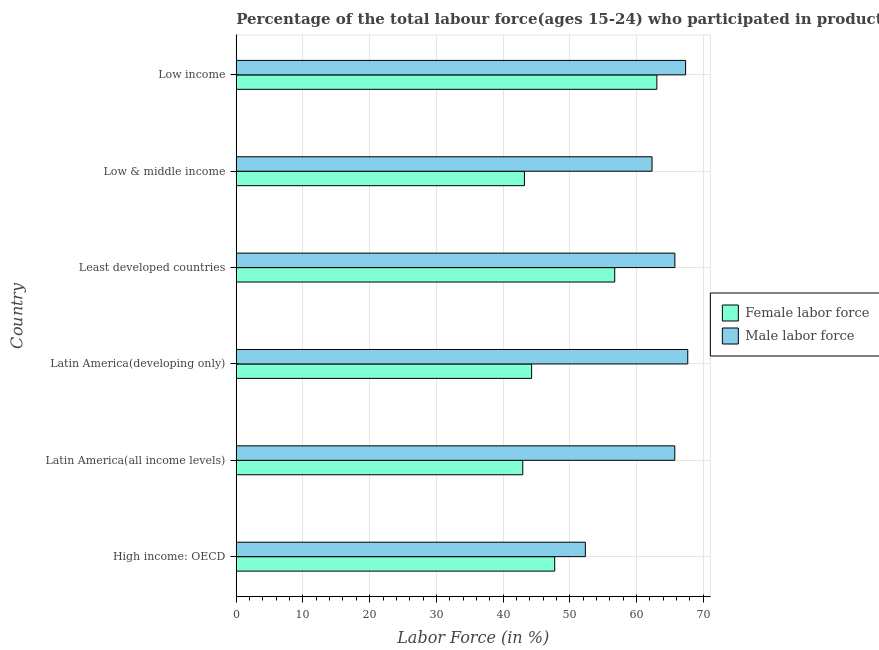How many different coloured bars are there?
Ensure brevity in your answer.  2. How many groups of bars are there?
Provide a succinct answer. 6. Are the number of bars per tick equal to the number of legend labels?
Keep it short and to the point. Yes. Are the number of bars on each tick of the Y-axis equal?
Provide a succinct answer. Yes. How many bars are there on the 5th tick from the bottom?
Your answer should be compact. 2. What is the label of the 1st group of bars from the top?
Offer a very short reply. Low income. What is the percentage of male labour force in Low income?
Give a very brief answer. 67.37. Across all countries, what is the maximum percentage of male labour force?
Offer a terse response. 67.69. Across all countries, what is the minimum percentage of male labour force?
Make the answer very short. 52.34. In which country was the percentage of male labour force maximum?
Provide a short and direct response. Latin America(developing only). In which country was the percentage of female labor force minimum?
Offer a very short reply. Latin America(all income levels). What is the total percentage of female labor force in the graph?
Offer a very short reply. 297.97. What is the difference between the percentage of male labour force in High income: OECD and that in Low & middle income?
Keep it short and to the point. -10. What is the difference between the percentage of female labor force in High income: OECD and the percentage of male labour force in Latin America(all income levels)?
Your response must be concise. -18.01. What is the average percentage of male labour force per country?
Keep it short and to the point. 63.54. What is the difference between the percentage of male labour force and percentage of female labor force in Low income?
Give a very brief answer. 4.31. What is the ratio of the percentage of male labour force in High income: OECD to that in Least developed countries?
Keep it short and to the point. 0.8. Is the percentage of male labour force in High income: OECD less than that in Least developed countries?
Your response must be concise. Yes. Is the difference between the percentage of female labor force in High income: OECD and Low income greater than the difference between the percentage of male labour force in High income: OECD and Low income?
Offer a very short reply. No. What is the difference between the highest and the second highest percentage of female labor force?
Your response must be concise. 6.32. What is the difference between the highest and the lowest percentage of female labor force?
Make the answer very short. 20.1. In how many countries, is the percentage of male labour force greater than the average percentage of male labour force taken over all countries?
Offer a very short reply. 4. Is the sum of the percentage of male labour force in Latin America(all income levels) and Latin America(developing only) greater than the maximum percentage of female labor force across all countries?
Your answer should be compact. Yes. What does the 2nd bar from the top in Latin America(developing only) represents?
Give a very brief answer. Female labor force. What does the 1st bar from the bottom in Low & middle income represents?
Keep it short and to the point. Female labor force. How many bars are there?
Offer a terse response. 12. Are all the bars in the graph horizontal?
Your answer should be compact. Yes. What is the difference between two consecutive major ticks on the X-axis?
Your answer should be very brief. 10. Does the graph contain any zero values?
Give a very brief answer. No. Does the graph contain grids?
Keep it short and to the point. Yes. How many legend labels are there?
Make the answer very short. 2. What is the title of the graph?
Provide a succinct answer. Percentage of the total labour force(ages 15-24) who participated in production in 2002. Does "Female" appear as one of the legend labels in the graph?
Make the answer very short. No. What is the label or title of the X-axis?
Give a very brief answer. Labor Force (in %). What is the Labor Force (in %) in Female labor force in High income: OECD?
Offer a very short reply. 47.74. What is the Labor Force (in %) in Male labor force in High income: OECD?
Your response must be concise. 52.34. What is the Labor Force (in %) of Female labor force in Latin America(all income levels)?
Your response must be concise. 42.95. What is the Labor Force (in %) in Male labor force in Latin America(all income levels)?
Your answer should be very brief. 65.75. What is the Labor Force (in %) in Female labor force in Latin America(developing only)?
Offer a very short reply. 44.28. What is the Labor Force (in %) in Male labor force in Latin America(developing only)?
Give a very brief answer. 67.69. What is the Labor Force (in %) of Female labor force in Least developed countries?
Make the answer very short. 56.74. What is the Labor Force (in %) of Male labor force in Least developed countries?
Give a very brief answer. 65.76. What is the Labor Force (in %) of Female labor force in Low & middle income?
Keep it short and to the point. 43.2. What is the Labor Force (in %) of Male labor force in Low & middle income?
Your answer should be very brief. 62.33. What is the Labor Force (in %) of Female labor force in Low income?
Give a very brief answer. 63.06. What is the Labor Force (in %) of Male labor force in Low income?
Provide a succinct answer. 67.37. Across all countries, what is the maximum Labor Force (in %) of Female labor force?
Provide a succinct answer. 63.06. Across all countries, what is the maximum Labor Force (in %) in Male labor force?
Your answer should be very brief. 67.69. Across all countries, what is the minimum Labor Force (in %) of Female labor force?
Give a very brief answer. 42.95. Across all countries, what is the minimum Labor Force (in %) in Male labor force?
Keep it short and to the point. 52.34. What is the total Labor Force (in %) in Female labor force in the graph?
Ensure brevity in your answer.  297.97. What is the total Labor Force (in %) of Male labor force in the graph?
Give a very brief answer. 381.23. What is the difference between the Labor Force (in %) in Female labor force in High income: OECD and that in Latin America(all income levels)?
Provide a short and direct response. 4.79. What is the difference between the Labor Force (in %) of Male labor force in High income: OECD and that in Latin America(all income levels)?
Offer a very short reply. -13.41. What is the difference between the Labor Force (in %) in Female labor force in High income: OECD and that in Latin America(developing only)?
Ensure brevity in your answer.  3.46. What is the difference between the Labor Force (in %) of Male labor force in High income: OECD and that in Latin America(developing only)?
Your response must be concise. -15.35. What is the difference between the Labor Force (in %) of Female labor force in High income: OECD and that in Least developed countries?
Your response must be concise. -9. What is the difference between the Labor Force (in %) of Male labor force in High income: OECD and that in Least developed countries?
Offer a very short reply. -13.42. What is the difference between the Labor Force (in %) in Female labor force in High income: OECD and that in Low & middle income?
Your answer should be very brief. 4.54. What is the difference between the Labor Force (in %) in Male labor force in High income: OECD and that in Low & middle income?
Keep it short and to the point. -10. What is the difference between the Labor Force (in %) of Female labor force in High income: OECD and that in Low income?
Ensure brevity in your answer.  -15.32. What is the difference between the Labor Force (in %) in Male labor force in High income: OECD and that in Low income?
Your response must be concise. -15.03. What is the difference between the Labor Force (in %) of Female labor force in Latin America(all income levels) and that in Latin America(developing only)?
Your response must be concise. -1.33. What is the difference between the Labor Force (in %) in Male labor force in Latin America(all income levels) and that in Latin America(developing only)?
Your answer should be compact. -1.94. What is the difference between the Labor Force (in %) of Female labor force in Latin America(all income levels) and that in Least developed countries?
Offer a very short reply. -13.78. What is the difference between the Labor Force (in %) in Male labor force in Latin America(all income levels) and that in Least developed countries?
Keep it short and to the point. -0.01. What is the difference between the Labor Force (in %) in Female labor force in Latin America(all income levels) and that in Low & middle income?
Provide a succinct answer. -0.25. What is the difference between the Labor Force (in %) of Male labor force in Latin America(all income levels) and that in Low & middle income?
Ensure brevity in your answer.  3.41. What is the difference between the Labor Force (in %) of Female labor force in Latin America(all income levels) and that in Low income?
Your answer should be very brief. -20.1. What is the difference between the Labor Force (in %) of Male labor force in Latin America(all income levels) and that in Low income?
Offer a very short reply. -1.62. What is the difference between the Labor Force (in %) of Female labor force in Latin America(developing only) and that in Least developed countries?
Your answer should be compact. -12.46. What is the difference between the Labor Force (in %) of Male labor force in Latin America(developing only) and that in Least developed countries?
Offer a terse response. 1.93. What is the difference between the Labor Force (in %) of Male labor force in Latin America(developing only) and that in Low & middle income?
Provide a succinct answer. 5.35. What is the difference between the Labor Force (in %) of Female labor force in Latin America(developing only) and that in Low income?
Ensure brevity in your answer.  -18.77. What is the difference between the Labor Force (in %) of Male labor force in Latin America(developing only) and that in Low income?
Offer a terse response. 0.32. What is the difference between the Labor Force (in %) of Female labor force in Least developed countries and that in Low & middle income?
Give a very brief answer. 13.53. What is the difference between the Labor Force (in %) in Male labor force in Least developed countries and that in Low & middle income?
Your answer should be very brief. 3.42. What is the difference between the Labor Force (in %) in Female labor force in Least developed countries and that in Low income?
Provide a succinct answer. -6.32. What is the difference between the Labor Force (in %) of Male labor force in Least developed countries and that in Low income?
Your response must be concise. -1.61. What is the difference between the Labor Force (in %) in Female labor force in Low & middle income and that in Low income?
Give a very brief answer. -19.85. What is the difference between the Labor Force (in %) of Male labor force in Low & middle income and that in Low income?
Make the answer very short. -5.04. What is the difference between the Labor Force (in %) in Female labor force in High income: OECD and the Labor Force (in %) in Male labor force in Latin America(all income levels)?
Keep it short and to the point. -18.01. What is the difference between the Labor Force (in %) of Female labor force in High income: OECD and the Labor Force (in %) of Male labor force in Latin America(developing only)?
Make the answer very short. -19.95. What is the difference between the Labor Force (in %) in Female labor force in High income: OECD and the Labor Force (in %) in Male labor force in Least developed countries?
Your answer should be very brief. -18.02. What is the difference between the Labor Force (in %) of Female labor force in High income: OECD and the Labor Force (in %) of Male labor force in Low & middle income?
Keep it short and to the point. -14.59. What is the difference between the Labor Force (in %) in Female labor force in High income: OECD and the Labor Force (in %) in Male labor force in Low income?
Your answer should be very brief. -19.63. What is the difference between the Labor Force (in %) in Female labor force in Latin America(all income levels) and the Labor Force (in %) in Male labor force in Latin America(developing only)?
Give a very brief answer. -24.74. What is the difference between the Labor Force (in %) in Female labor force in Latin America(all income levels) and the Labor Force (in %) in Male labor force in Least developed countries?
Make the answer very short. -22.8. What is the difference between the Labor Force (in %) of Female labor force in Latin America(all income levels) and the Labor Force (in %) of Male labor force in Low & middle income?
Keep it short and to the point. -19.38. What is the difference between the Labor Force (in %) of Female labor force in Latin America(all income levels) and the Labor Force (in %) of Male labor force in Low income?
Ensure brevity in your answer.  -24.42. What is the difference between the Labor Force (in %) in Female labor force in Latin America(developing only) and the Labor Force (in %) in Male labor force in Least developed countries?
Ensure brevity in your answer.  -21.48. What is the difference between the Labor Force (in %) of Female labor force in Latin America(developing only) and the Labor Force (in %) of Male labor force in Low & middle income?
Provide a short and direct response. -18.05. What is the difference between the Labor Force (in %) in Female labor force in Latin America(developing only) and the Labor Force (in %) in Male labor force in Low income?
Make the answer very short. -23.09. What is the difference between the Labor Force (in %) of Female labor force in Least developed countries and the Labor Force (in %) of Male labor force in Low & middle income?
Provide a short and direct response. -5.6. What is the difference between the Labor Force (in %) in Female labor force in Least developed countries and the Labor Force (in %) in Male labor force in Low income?
Your answer should be very brief. -10.63. What is the difference between the Labor Force (in %) of Female labor force in Low & middle income and the Labor Force (in %) of Male labor force in Low income?
Ensure brevity in your answer.  -24.16. What is the average Labor Force (in %) of Female labor force per country?
Your answer should be compact. 49.66. What is the average Labor Force (in %) of Male labor force per country?
Your answer should be compact. 63.54. What is the difference between the Labor Force (in %) in Female labor force and Labor Force (in %) in Male labor force in High income: OECD?
Give a very brief answer. -4.6. What is the difference between the Labor Force (in %) of Female labor force and Labor Force (in %) of Male labor force in Latin America(all income levels)?
Your answer should be very brief. -22.79. What is the difference between the Labor Force (in %) of Female labor force and Labor Force (in %) of Male labor force in Latin America(developing only)?
Offer a very short reply. -23.41. What is the difference between the Labor Force (in %) in Female labor force and Labor Force (in %) in Male labor force in Least developed countries?
Your response must be concise. -9.02. What is the difference between the Labor Force (in %) of Female labor force and Labor Force (in %) of Male labor force in Low & middle income?
Provide a succinct answer. -19.13. What is the difference between the Labor Force (in %) in Female labor force and Labor Force (in %) in Male labor force in Low income?
Your response must be concise. -4.31. What is the ratio of the Labor Force (in %) of Female labor force in High income: OECD to that in Latin America(all income levels)?
Offer a terse response. 1.11. What is the ratio of the Labor Force (in %) in Male labor force in High income: OECD to that in Latin America(all income levels)?
Your response must be concise. 0.8. What is the ratio of the Labor Force (in %) in Female labor force in High income: OECD to that in Latin America(developing only)?
Provide a succinct answer. 1.08. What is the ratio of the Labor Force (in %) in Male labor force in High income: OECD to that in Latin America(developing only)?
Make the answer very short. 0.77. What is the ratio of the Labor Force (in %) of Female labor force in High income: OECD to that in Least developed countries?
Ensure brevity in your answer.  0.84. What is the ratio of the Labor Force (in %) of Male labor force in High income: OECD to that in Least developed countries?
Provide a succinct answer. 0.8. What is the ratio of the Labor Force (in %) in Female labor force in High income: OECD to that in Low & middle income?
Provide a succinct answer. 1.1. What is the ratio of the Labor Force (in %) of Male labor force in High income: OECD to that in Low & middle income?
Your response must be concise. 0.84. What is the ratio of the Labor Force (in %) in Female labor force in High income: OECD to that in Low income?
Ensure brevity in your answer.  0.76. What is the ratio of the Labor Force (in %) in Male labor force in High income: OECD to that in Low income?
Give a very brief answer. 0.78. What is the ratio of the Labor Force (in %) of Female labor force in Latin America(all income levels) to that in Latin America(developing only)?
Offer a very short reply. 0.97. What is the ratio of the Labor Force (in %) of Male labor force in Latin America(all income levels) to that in Latin America(developing only)?
Your response must be concise. 0.97. What is the ratio of the Labor Force (in %) of Female labor force in Latin America(all income levels) to that in Least developed countries?
Ensure brevity in your answer.  0.76. What is the ratio of the Labor Force (in %) of Male labor force in Latin America(all income levels) to that in Least developed countries?
Your answer should be compact. 1. What is the ratio of the Labor Force (in %) of Male labor force in Latin America(all income levels) to that in Low & middle income?
Provide a short and direct response. 1.05. What is the ratio of the Labor Force (in %) in Female labor force in Latin America(all income levels) to that in Low income?
Your answer should be very brief. 0.68. What is the ratio of the Labor Force (in %) in Male labor force in Latin America(all income levels) to that in Low income?
Make the answer very short. 0.98. What is the ratio of the Labor Force (in %) in Female labor force in Latin America(developing only) to that in Least developed countries?
Provide a succinct answer. 0.78. What is the ratio of the Labor Force (in %) in Male labor force in Latin America(developing only) to that in Least developed countries?
Give a very brief answer. 1.03. What is the ratio of the Labor Force (in %) in Female labor force in Latin America(developing only) to that in Low & middle income?
Provide a short and direct response. 1.02. What is the ratio of the Labor Force (in %) in Male labor force in Latin America(developing only) to that in Low & middle income?
Provide a short and direct response. 1.09. What is the ratio of the Labor Force (in %) in Female labor force in Latin America(developing only) to that in Low income?
Give a very brief answer. 0.7. What is the ratio of the Labor Force (in %) in Female labor force in Least developed countries to that in Low & middle income?
Provide a succinct answer. 1.31. What is the ratio of the Labor Force (in %) in Male labor force in Least developed countries to that in Low & middle income?
Keep it short and to the point. 1.05. What is the ratio of the Labor Force (in %) in Female labor force in Least developed countries to that in Low income?
Ensure brevity in your answer.  0.9. What is the ratio of the Labor Force (in %) in Male labor force in Least developed countries to that in Low income?
Your response must be concise. 0.98. What is the ratio of the Labor Force (in %) of Female labor force in Low & middle income to that in Low income?
Your response must be concise. 0.69. What is the ratio of the Labor Force (in %) in Male labor force in Low & middle income to that in Low income?
Give a very brief answer. 0.93. What is the difference between the highest and the second highest Labor Force (in %) in Female labor force?
Provide a short and direct response. 6.32. What is the difference between the highest and the second highest Labor Force (in %) of Male labor force?
Your answer should be very brief. 0.32. What is the difference between the highest and the lowest Labor Force (in %) in Female labor force?
Your answer should be very brief. 20.1. What is the difference between the highest and the lowest Labor Force (in %) of Male labor force?
Keep it short and to the point. 15.35. 